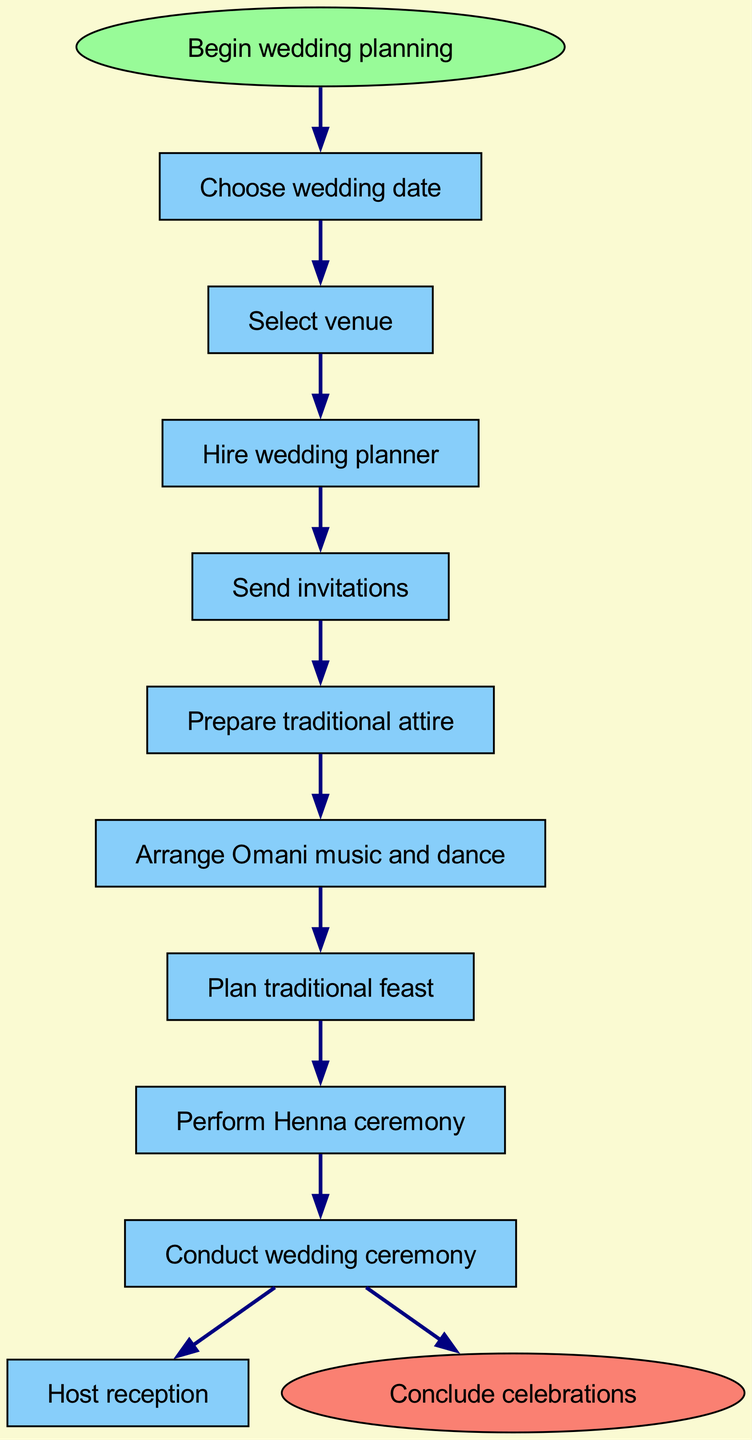What is the first step in the wedding planning procedure? The first step is clearly indicated as "Choose wedding date," which is the step right after the start node labeled "Begin wedding planning."
Answer: Choose wedding date How many steps are there in total? By counting the steps outlined in the diagram, including the start and end nodes, there are 9 steps in total, specifically listed in the data as part of the procedural flow.
Answer: 9 What is the last action before concluding celebrations? The last action, right before reaching the end node labeled "Conclude celebrations," is identified as "Host reception," which is the final step in the series before concluding.
Answer: Host reception Which step follows "Arrange Omani music and dance"? After reviewing the flow from "Arrange Omani music and dance," the next step listed is "Plan traditional feast," indicating the direct continuation in the procedure.
Answer: Plan traditional feast What color is the start node? The start node, which signifies the beginning of the wedding planning procedure, is filled with a color specified as "palegreen" in the diagram attributes, describing its visual appearance.
Answer: Palegreen What is the relationship between "Send invitations" and "Prepare traditional attire"? The relationship can be identified through the directional flow established in the diagram, where "Send invitations" directly leads to "Prepare traditional attire," indicating a sequential connection in the process.
Answer: Sequential connection What node is connected to the end node? The node connected directly to the end node, which concludes the wedding planning procedure, is "Conduct wedding ceremony," establishing it as the final step before reaching the end.
Answer: Conduct wedding ceremony How many steps are there from "Send invitations" to "Host reception"? By counting the nodes from "Send invitations" to "Host reception," there are 4 steps in total: "Send invitations," "Prepare traditional attire," "Arrange Omani music and dance," and "Plan traditional feast."
Answer: 4 steps What is the second step in the procedure? The second step, based on the sequential flow after the first step "Choose wedding date," is indicated in the diagram as "Select venue," establishing it as the next action in the planning process.
Answer: Select venue 